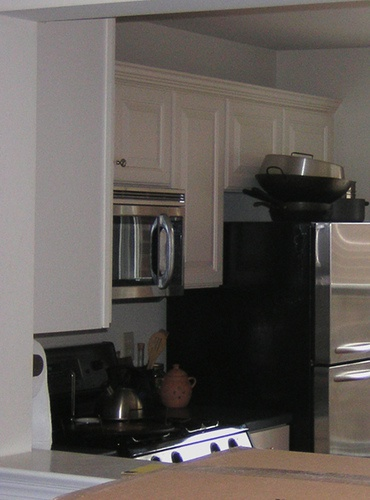Describe the objects in this image and their specific colors. I can see refrigerator in darkgray, black, and gray tones, oven in darkgray, black, lightgray, gray, and navy tones, and microwave in darkgray, black, and gray tones in this image. 